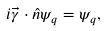Convert formula to latex. <formula><loc_0><loc_0><loc_500><loc_500>i \vec { \gamma } \cdot \hat { n } \psi _ { q } = \psi _ { q } ,</formula> 